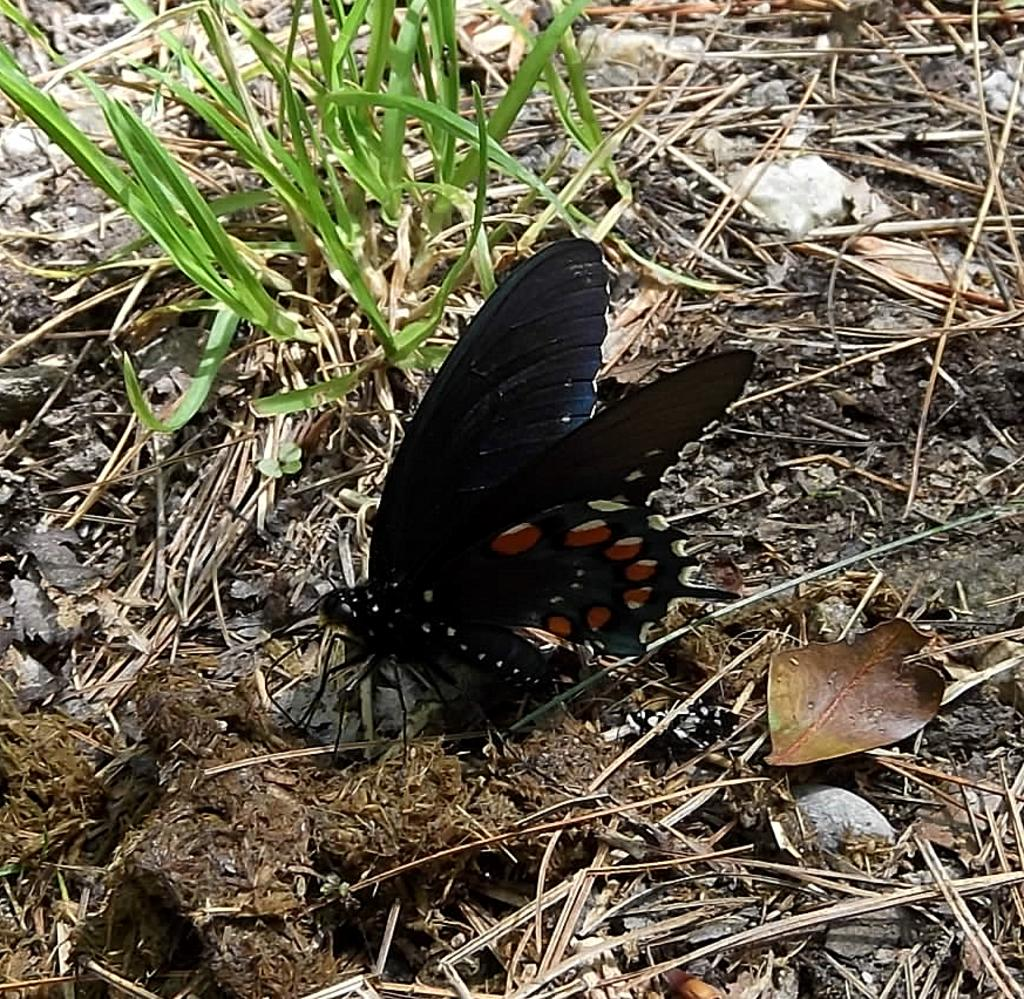What is the main subject in the center of the image? There is a butterfly in the center of the image. What type of vegetation is present at the bottom of the image? There is dried grass at the bottom of the image. Can you see a flock of butterflies flying over a river in the image? There is no flock of butterflies or river present in the image; it only features a single butterfly and dried grass. 